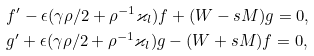Convert formula to latex. <formula><loc_0><loc_0><loc_500><loc_500>& f ^ { \prime } - \epsilon ( \gamma \rho / 2 + \rho ^ { - 1 } \varkappa _ { l } ) f + ( W - s M ) g = 0 , \\ & g ^ { \prime } + \epsilon ( \gamma \rho / 2 + \rho ^ { - 1 } \varkappa _ { l } ) g - ( W + s M ) f = 0 ,</formula> 